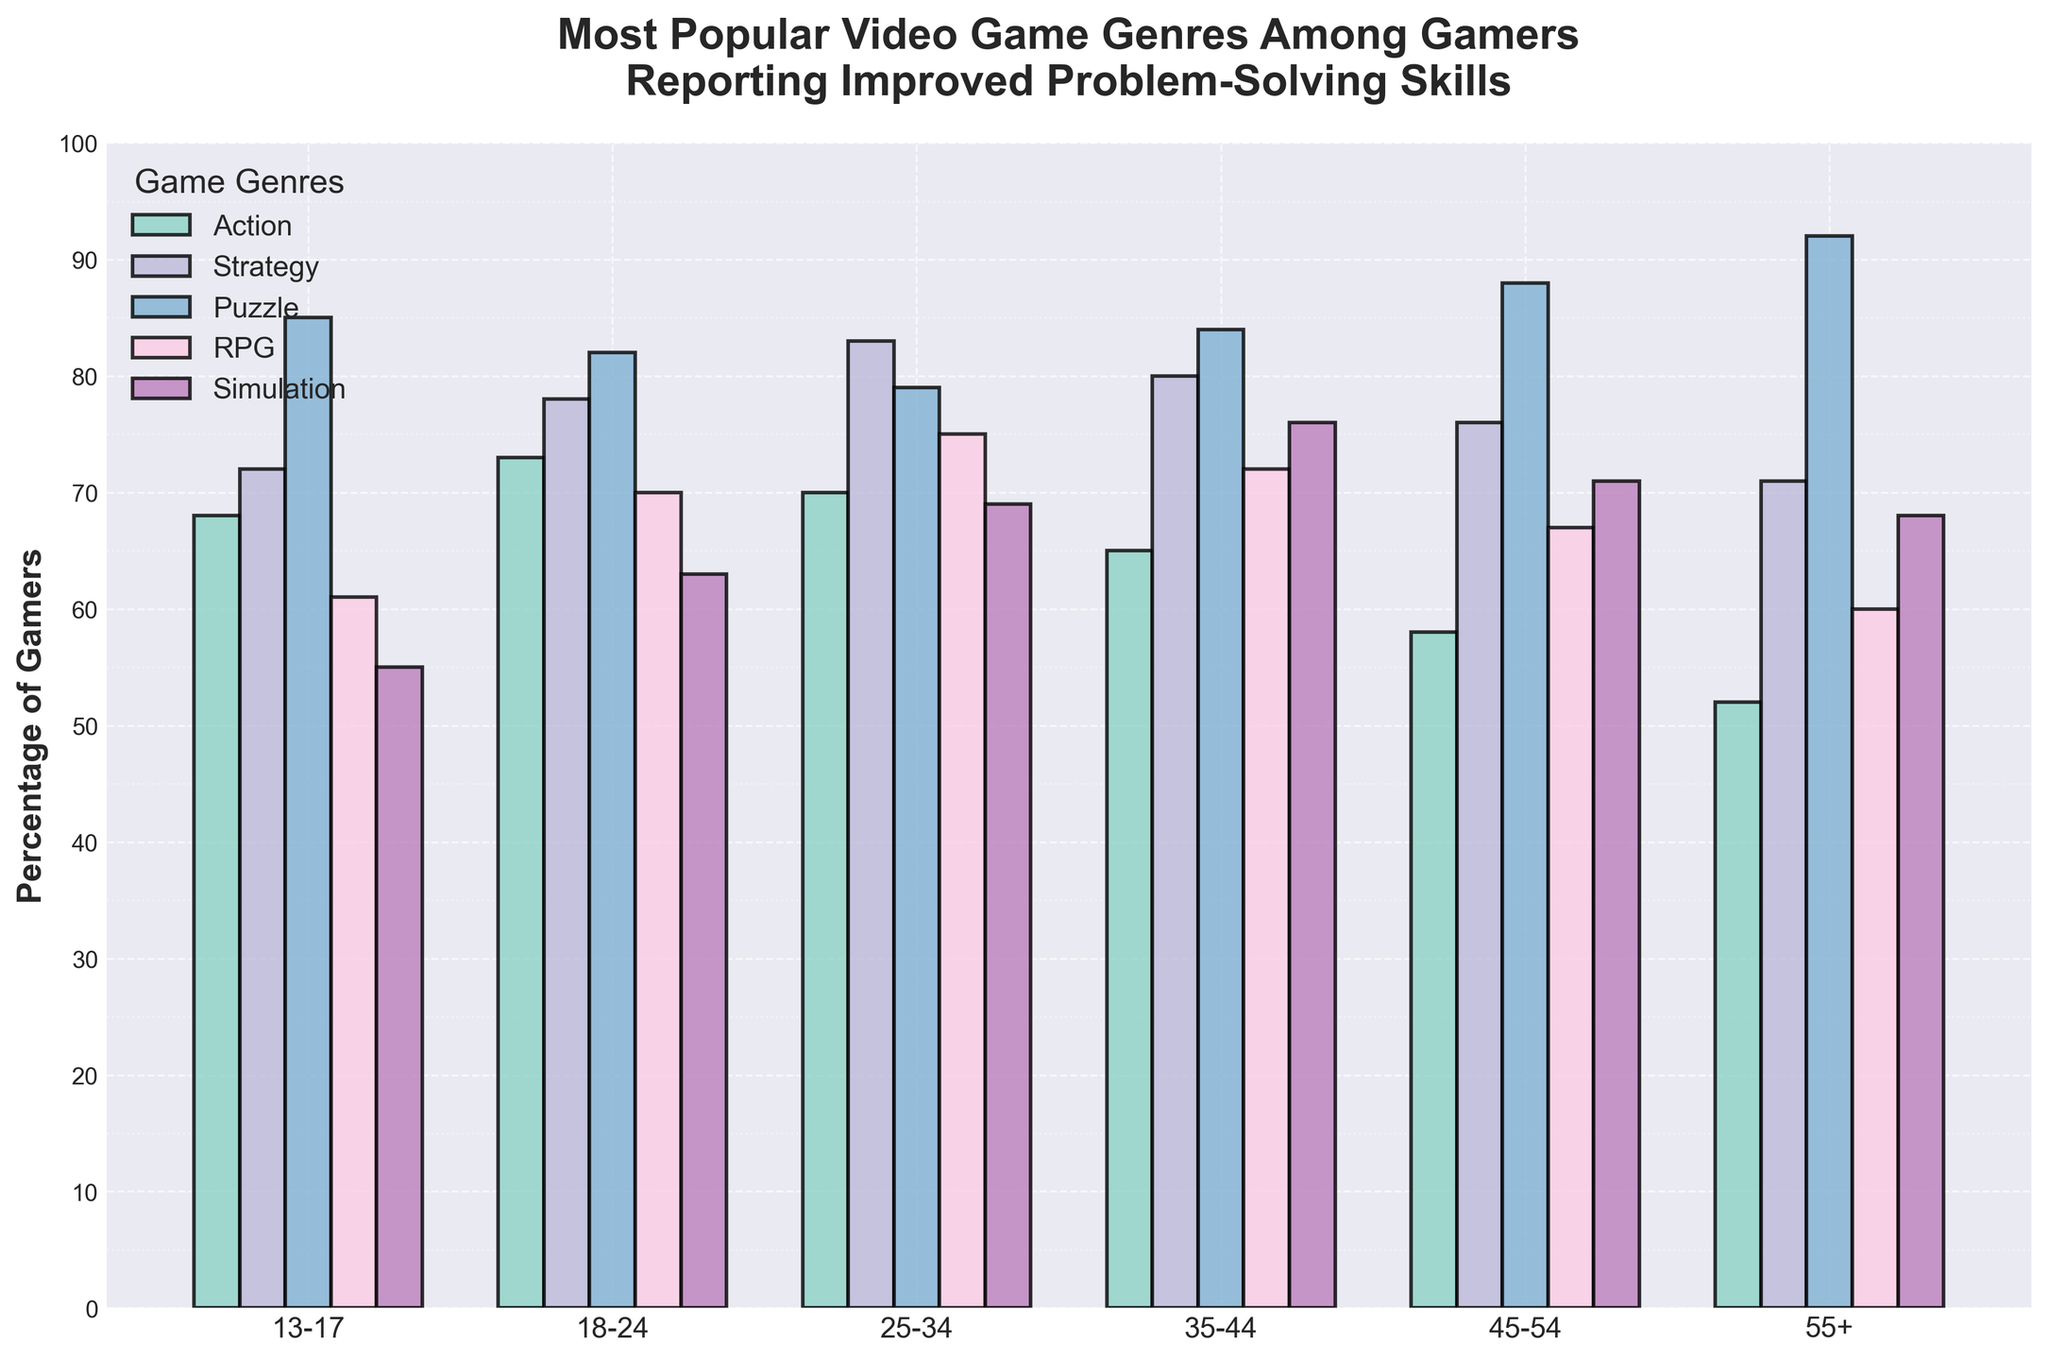What age group shows the highest percentage for the Puzzle genre? The bar for the Puzzle genre is the tallest for the age group 55+, indicating the highest percentage.
Answer: 55+ Which genre is more popular among the 35-44 age group, Strategy or RPG? By comparing the heights of the bars for the Strategy and RPG genres in the 35-44 age group, the Strategy bar is higher.
Answer: Strategy What is the difference in popularity between the Simulation genre in the 45-54 age group and the 18-24 age group? The height of the Simulation bar in the 45-54 age group is 71, and in the 18-24 age group is 63. The difference is 71 - 63.
Answer: 8 What is the average percentage of gamers who favor Action across all age groups? Sum the percentages for Action in all age groups (68 + 73 + 70 + 65 + 58 + 52) and divide by the number of age groups (6).
Answer: 64.33 Which genre shows the greatest increase in popularity from the 13-17 age group to the 25-34 age group? By comparing the bars of each genre between the 13-17 and 25-34 age groups, the Strategy genre has the highest increase from 72 to 83.
Answer: Strategy For the Puzzle genre, how much higher is the percentage in the 55+ age group compared to the 18-24 age group? The height of the Puzzle bar in the 55+ age group is 92, and in the 18-24 age group is 82. The difference is 92 - 82.
Answer: 10 Which age group has the lowest percentage for the RPG genre? By comparing the heights of the RPG bars across all age groups, the 13-17 and 55+ age groups have the lowest bars with the same height of 61.
Answer: 13-17 and 55+ Is the Simulation genre more popular among the 35-44 age group or the 25-34 age group? By comparing the heights of the Simulation bars between the 35-44 and 25-34 age groups, the bar in the 35-44 age group is higher.
Answer: 35-44 What is the total percentage of gamers favoring the Strategy genre across all age groups? Sum the percentages for the Strategy genre in all age groups (72 + 78 + 83 + 80 + 76 + 71).
Answer: 460 Which genre has the smallest variation in popularity across all age groups? By observing the differences in heights of bars for each genre, the Simulation genre has the smallest overall difference between the highest and lowest values.
Answer: Simulation 